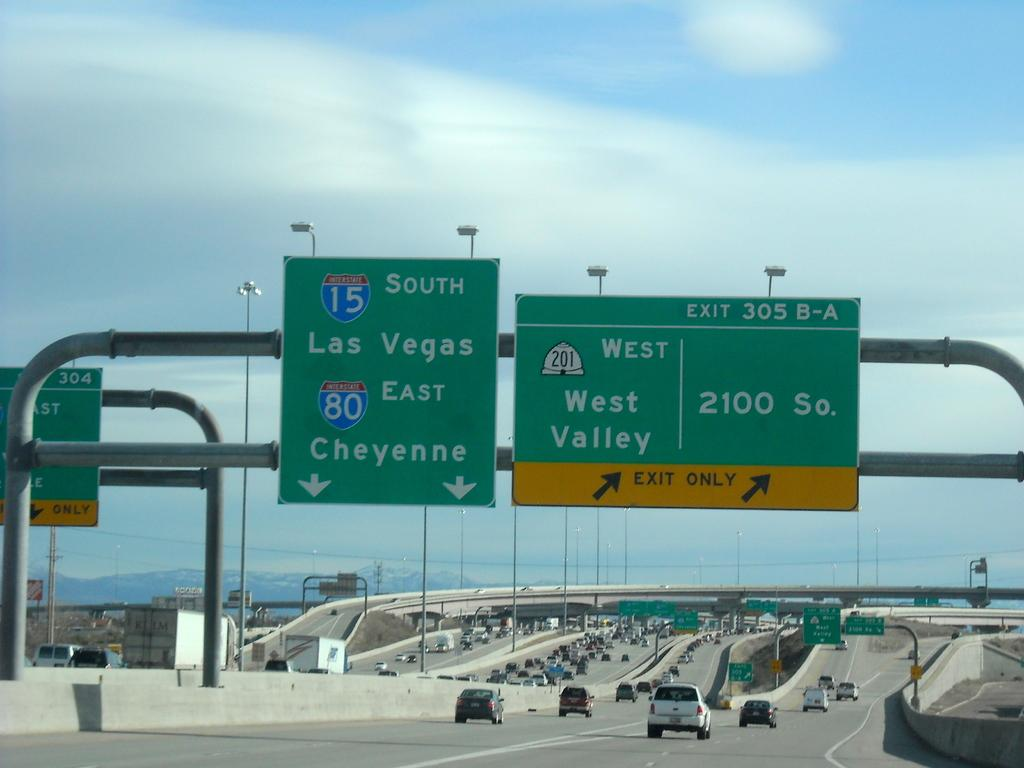<image>
Present a compact description of the photo's key features. Green and yellow signs with the words West Valley and Las Vegas South with cars below. 